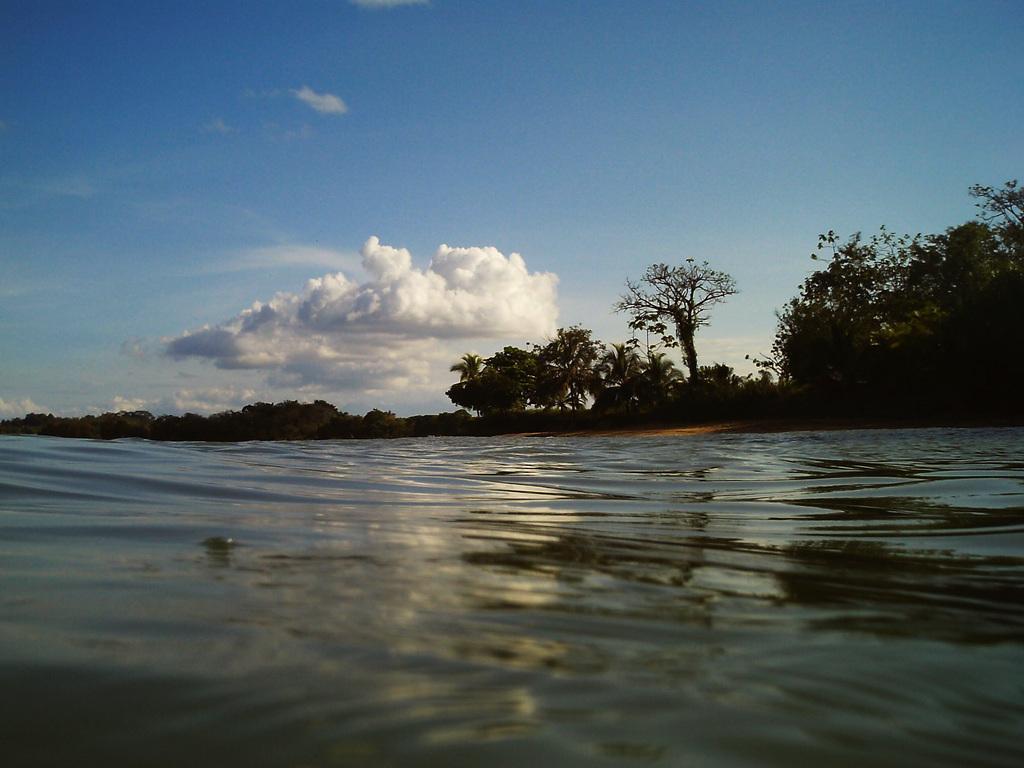How would you summarize this image in a sentence or two? In this picture I can see trees and water and a blue cloudy sky. 